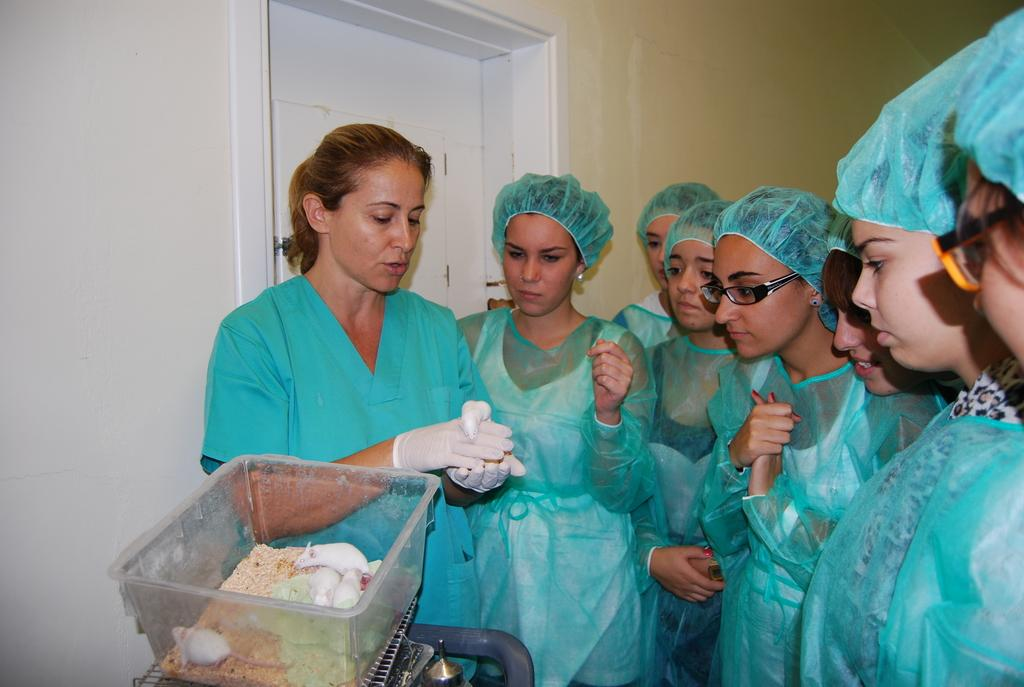Who is present in the image? There are women in the image. What are the women wearing? The women are wearing green dresses. What is located in front of the women? There is a box in front of the women. What is inside the box? The box contains rats and other objects. What can be seen in the background of the image? There is a door visible in the background of the image. What type of garden can be seen in the image? There is no garden present in the image. What achievements have the women in the image accomplished? The image does not provide information about the women's achievements. 